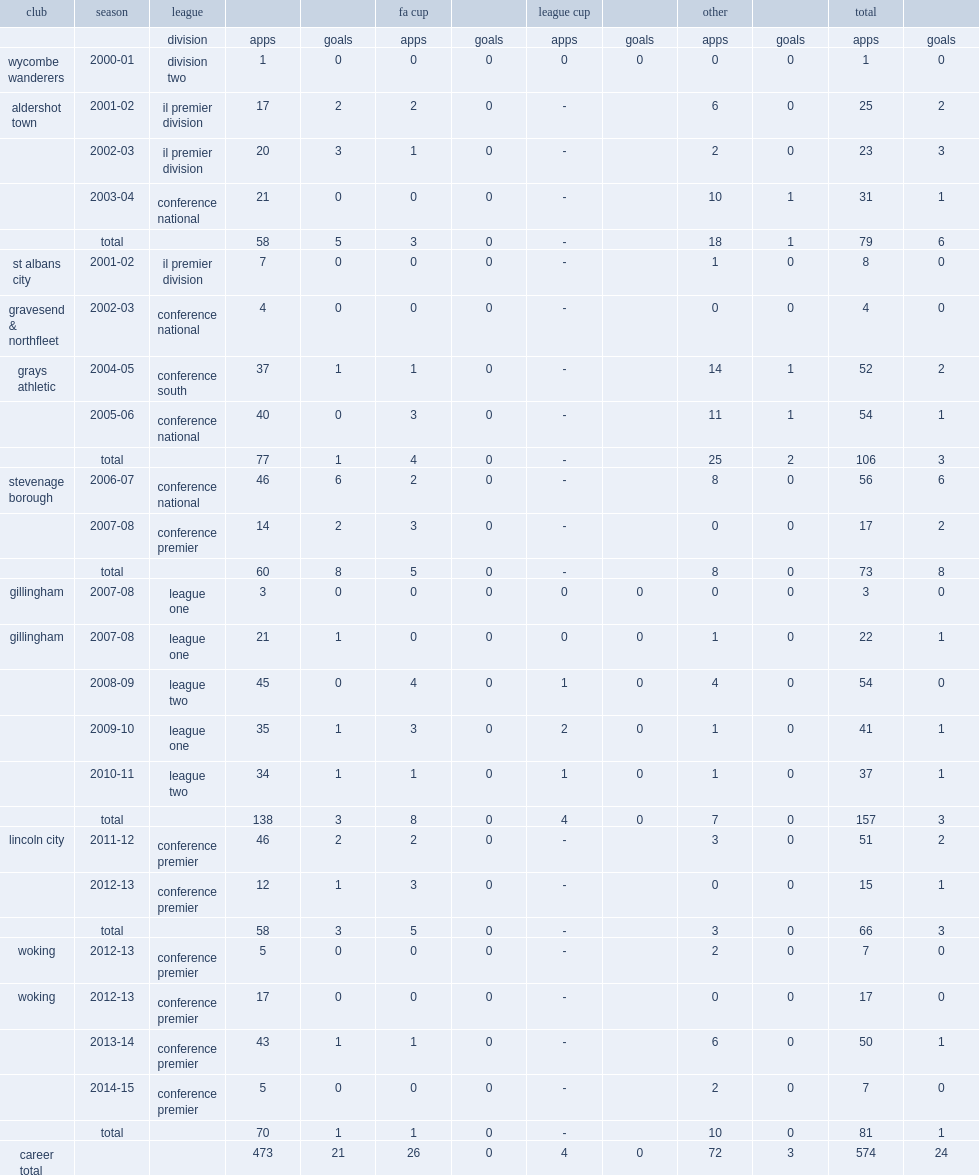When did nutter play on the conference south club grays athletic? 2004-05. 